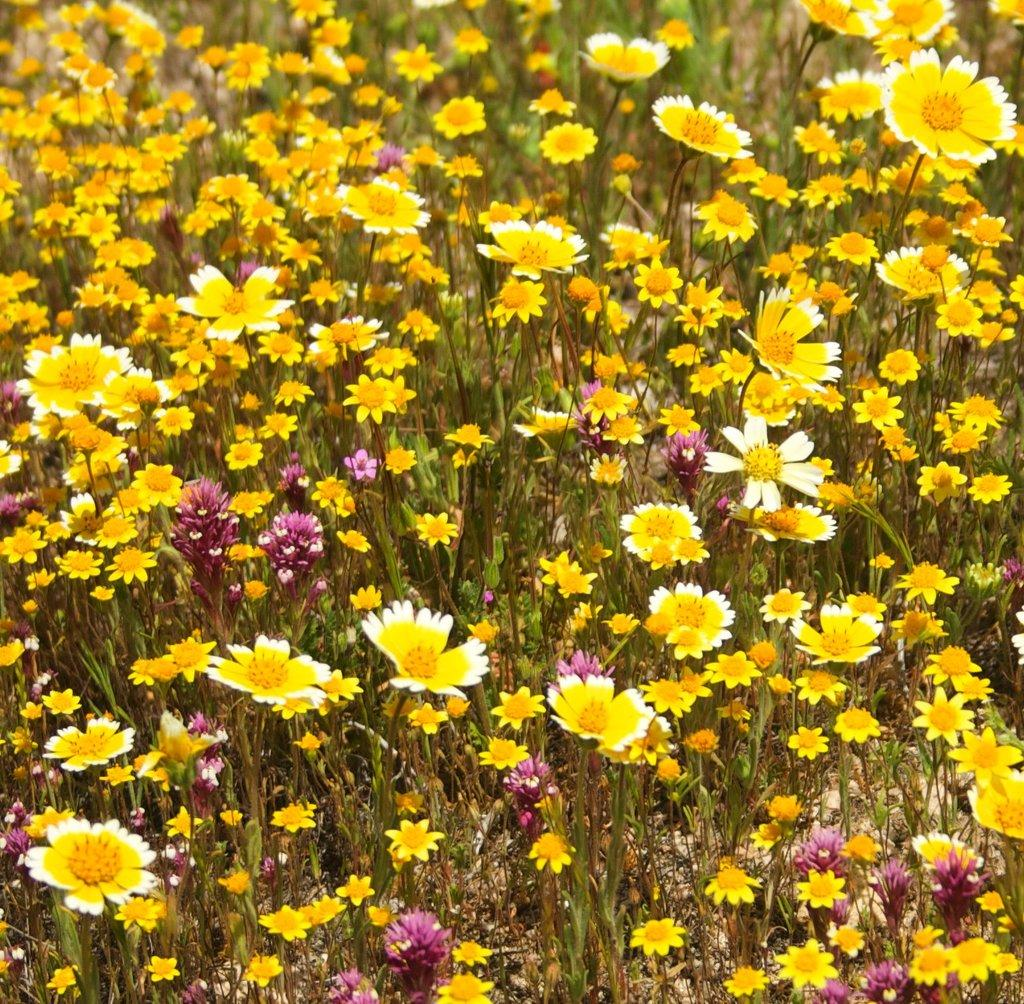What is located in the center of the image? There are flowers and plants in the center of the image. Can you describe the flowers in the image? The provided facts do not include specific details about the flowers, so we cannot describe them. What else is present in the center of the image besides the flowers? There are plants in the center of the image. What type of request can be seen in the image? There is no request present in the image; it features flowers and plants. How many teeth can be seen in the image? There are no teeth present in the image; it features flowers and plants. 